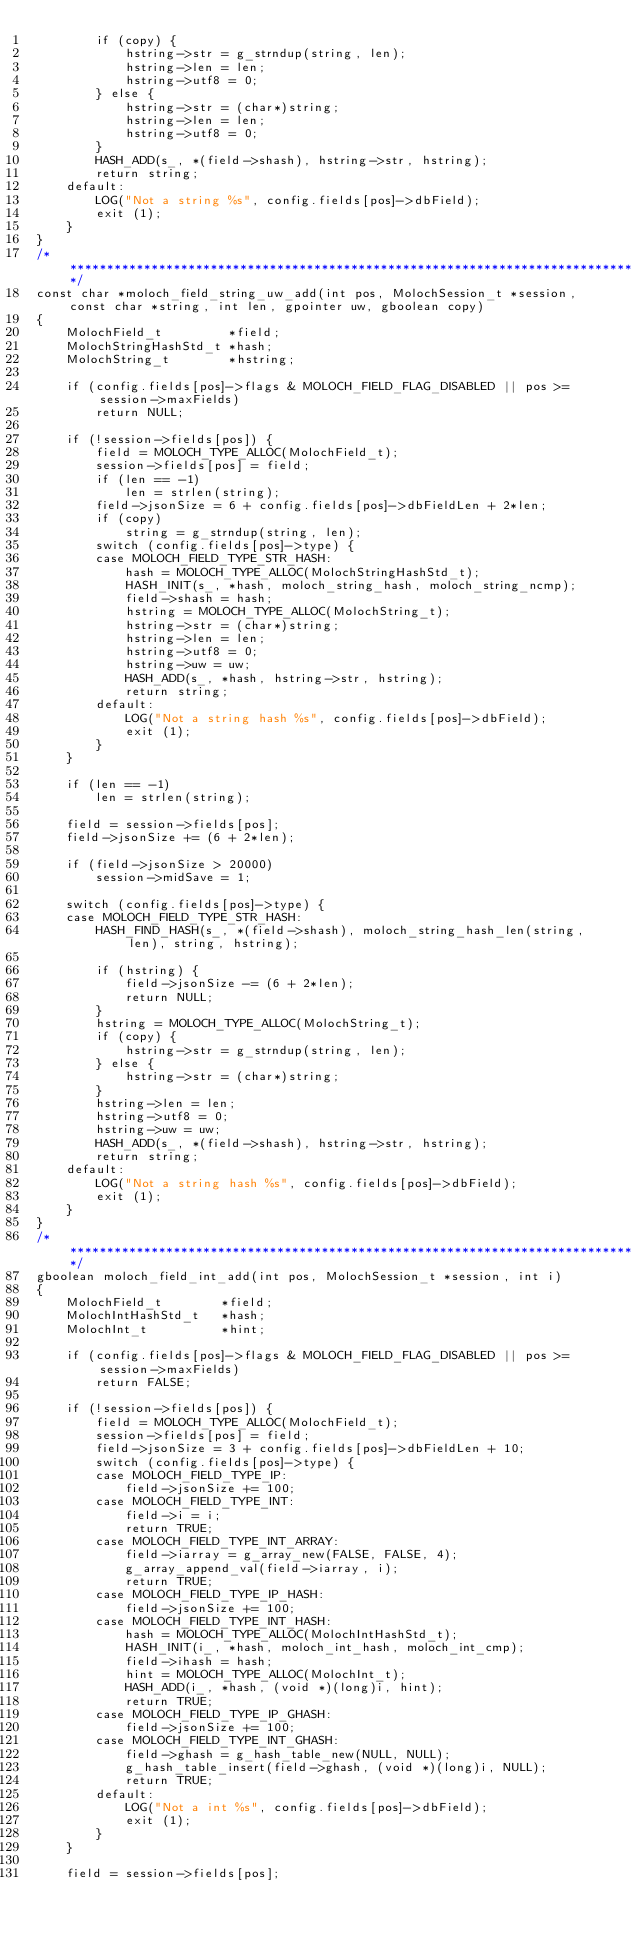<code> <loc_0><loc_0><loc_500><loc_500><_C_>        if (copy) {
            hstring->str = g_strndup(string, len);
            hstring->len = len;
            hstring->utf8 = 0;
        } else {
            hstring->str = (char*)string;
            hstring->len = len;
            hstring->utf8 = 0;
        }
        HASH_ADD(s_, *(field->shash), hstring->str, hstring);
        return string;
    default:
        LOG("Not a string %s", config.fields[pos]->dbField);
        exit (1);
    }
}
/******************************************************************************/
const char *moloch_field_string_uw_add(int pos, MolochSession_t *session, const char *string, int len, gpointer uw, gboolean copy)
{
    MolochField_t         *field;
    MolochStringHashStd_t *hash;
    MolochString_t        *hstring;

    if (config.fields[pos]->flags & MOLOCH_FIELD_FLAG_DISABLED || pos >= session->maxFields)
        return NULL;

    if (!session->fields[pos]) {
        field = MOLOCH_TYPE_ALLOC(MolochField_t);
        session->fields[pos] = field;
        if (len == -1)
            len = strlen(string);
        field->jsonSize = 6 + config.fields[pos]->dbFieldLen + 2*len;
        if (copy)
            string = g_strndup(string, len);
        switch (config.fields[pos]->type) {
        case MOLOCH_FIELD_TYPE_STR_HASH:
            hash = MOLOCH_TYPE_ALLOC(MolochStringHashStd_t);
            HASH_INIT(s_, *hash, moloch_string_hash, moloch_string_ncmp);
            field->shash = hash;
            hstring = MOLOCH_TYPE_ALLOC(MolochString_t);
            hstring->str = (char*)string;
            hstring->len = len;
            hstring->utf8 = 0;
            hstring->uw = uw;
            HASH_ADD(s_, *hash, hstring->str, hstring);
            return string;
        default:
            LOG("Not a string hash %s", config.fields[pos]->dbField);
            exit (1);
        }
    }

    if (len == -1)
        len = strlen(string);

    field = session->fields[pos];
    field->jsonSize += (6 + 2*len);

    if (field->jsonSize > 20000)
        session->midSave = 1;

    switch (config.fields[pos]->type) {
    case MOLOCH_FIELD_TYPE_STR_HASH:
        HASH_FIND_HASH(s_, *(field->shash), moloch_string_hash_len(string, len), string, hstring);

        if (hstring) {
            field->jsonSize -= (6 + 2*len);
            return NULL;
        }
        hstring = MOLOCH_TYPE_ALLOC(MolochString_t);
        if (copy) {
            hstring->str = g_strndup(string, len);
        } else {
            hstring->str = (char*)string;
        }
        hstring->len = len;
        hstring->utf8 = 0;
        hstring->uw = uw;
        HASH_ADD(s_, *(field->shash), hstring->str, hstring);
        return string;
    default:
        LOG("Not a string hash %s", config.fields[pos]->dbField);
        exit (1);
    }
}
/******************************************************************************/
gboolean moloch_field_int_add(int pos, MolochSession_t *session, int i)
{
    MolochField_t        *field;
    MolochIntHashStd_t   *hash;
    MolochInt_t          *hint;

    if (config.fields[pos]->flags & MOLOCH_FIELD_FLAG_DISABLED || pos >= session->maxFields)
        return FALSE;

    if (!session->fields[pos]) {
        field = MOLOCH_TYPE_ALLOC(MolochField_t);
        session->fields[pos] = field;
        field->jsonSize = 3 + config.fields[pos]->dbFieldLen + 10;
        switch (config.fields[pos]->type) {
        case MOLOCH_FIELD_TYPE_IP:
            field->jsonSize += 100;
        case MOLOCH_FIELD_TYPE_INT:
            field->i = i;
            return TRUE;
        case MOLOCH_FIELD_TYPE_INT_ARRAY:
            field->iarray = g_array_new(FALSE, FALSE, 4);
            g_array_append_val(field->iarray, i);
            return TRUE;
        case MOLOCH_FIELD_TYPE_IP_HASH:
            field->jsonSize += 100;
        case MOLOCH_FIELD_TYPE_INT_HASH:
            hash = MOLOCH_TYPE_ALLOC(MolochIntHashStd_t);
            HASH_INIT(i_, *hash, moloch_int_hash, moloch_int_cmp);
            field->ihash = hash;
            hint = MOLOCH_TYPE_ALLOC(MolochInt_t);
            HASH_ADD(i_, *hash, (void *)(long)i, hint);
            return TRUE;
        case MOLOCH_FIELD_TYPE_IP_GHASH:
            field->jsonSize += 100;
        case MOLOCH_FIELD_TYPE_INT_GHASH:
            field->ghash = g_hash_table_new(NULL, NULL);
            g_hash_table_insert(field->ghash, (void *)(long)i, NULL);
            return TRUE;
        default:
            LOG("Not a int %s", config.fields[pos]->dbField);
            exit (1);
        }
    }

    field = session->fields[pos];</code> 